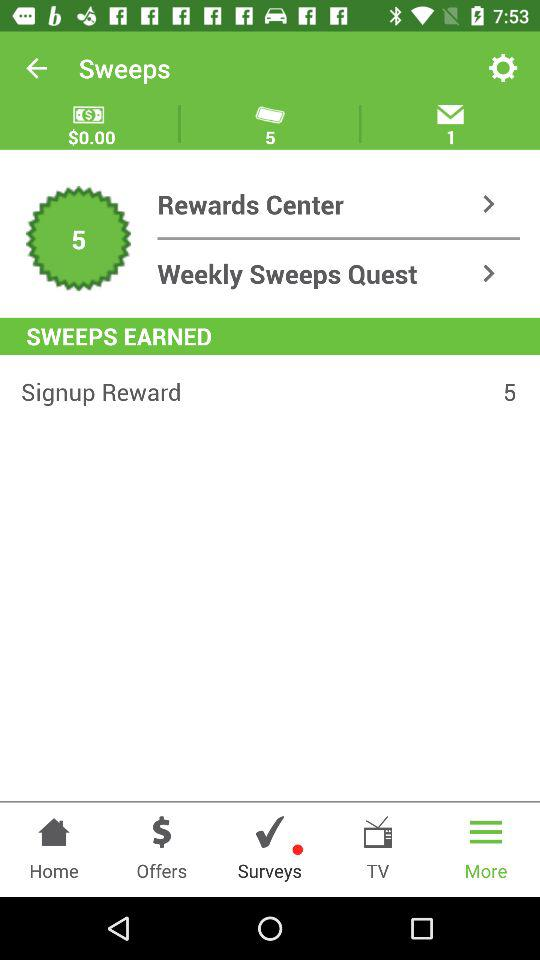How many more sweeps have I earned since signing up?
Answer the question using a single word or phrase. 5 